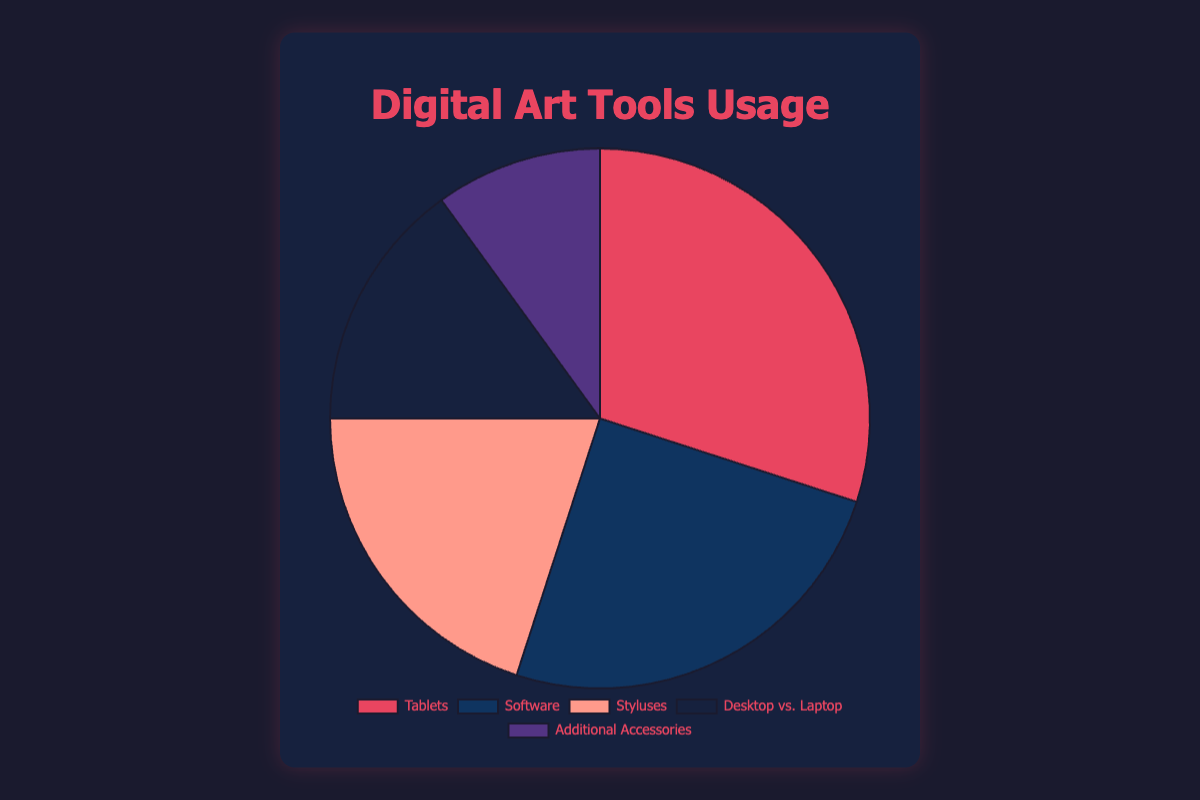What percentage of digital artists use styluses? The pie chart shows that 20% of digital artists use styluses. Look at the segment labeled 'Styluses' and read the number inside.
Answer: 20% Which category has the highest usage among digital artists? The segment with the largest slice in the pie chart represents Tablets, which has the highest percentage at 30%.
Answer: Tablets How much more popular are tablets compared to additional accessories? Tablets have a usage of 30%, while additional accessories have 10%. The difference is 30% - 10% = 20%.
Answer: 20% What is the combined usage percentage of software and styluses? Add the usage percentages of software (25%) and styluses (20%). 25% + 20% = 45%.
Answer: 45% Which category is more commonly used: desktops vs. laptops or software? The pie chart shows Software usage at 25% and Desktop vs. Laptop usage at 15%. Since 25% is greater than 15%, software is more commonly used.
Answer: Software What color represents the 'Additional Accessories' category in the pie chart? The segment for 'Additional Accessories' is colored purple.
Answer: Purple What is the average percentage of usage for Tablets, Software, and Styluses? Add the percentages of Tablets (30%), Software (25%), and Styluses (20%) and then divide by 3. (30 + 25 + 20) / 3 = 75 / 3 = 25%.
Answer: 25% Is the usage of desktops vs. laptops equal to the sum of styluses and additional accessories? Styluses are 20% and additional accessories are 10%. Their sum is 20% + 10% = 30%. Desktops vs. Laptops usage is 15%, so it is not equal to 30%.
Answer: No If you combine the categories of desktops vs. laptops and additional accessories, what percentage of artists use them? Add the percentages of Desktops vs. Laptops (15%) and Additional Accessories (10%). 15% + 10% = 25%.
Answer: 25% Which category is represented by the largest slice in a dark blue color? The dark blue segment represents Software.
Answer: Software 